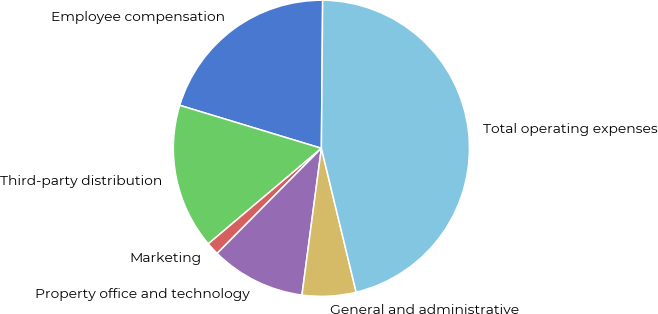Convert chart to OTSL. <chart><loc_0><loc_0><loc_500><loc_500><pie_chart><fcel>Employee compensation<fcel>Third-party distribution<fcel>Marketing<fcel>Property office and technology<fcel>General and administrative<fcel>Total operating expenses<nl><fcel>20.45%<fcel>15.85%<fcel>1.4%<fcel>10.34%<fcel>5.87%<fcel>46.09%<nl></chart> 